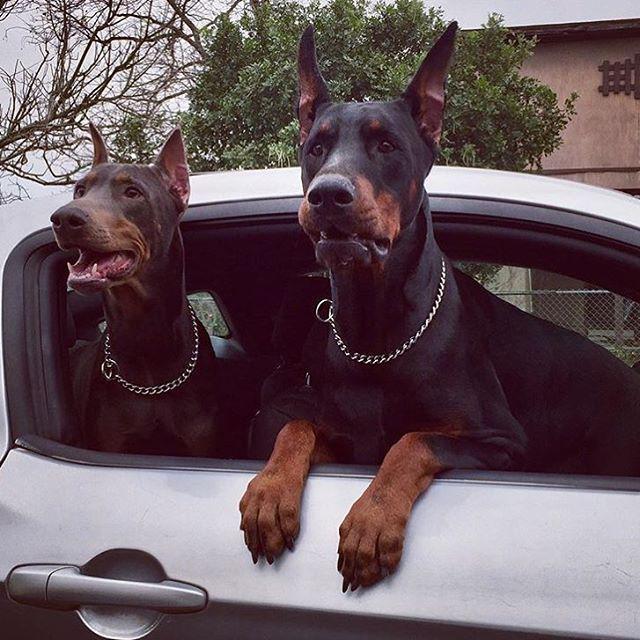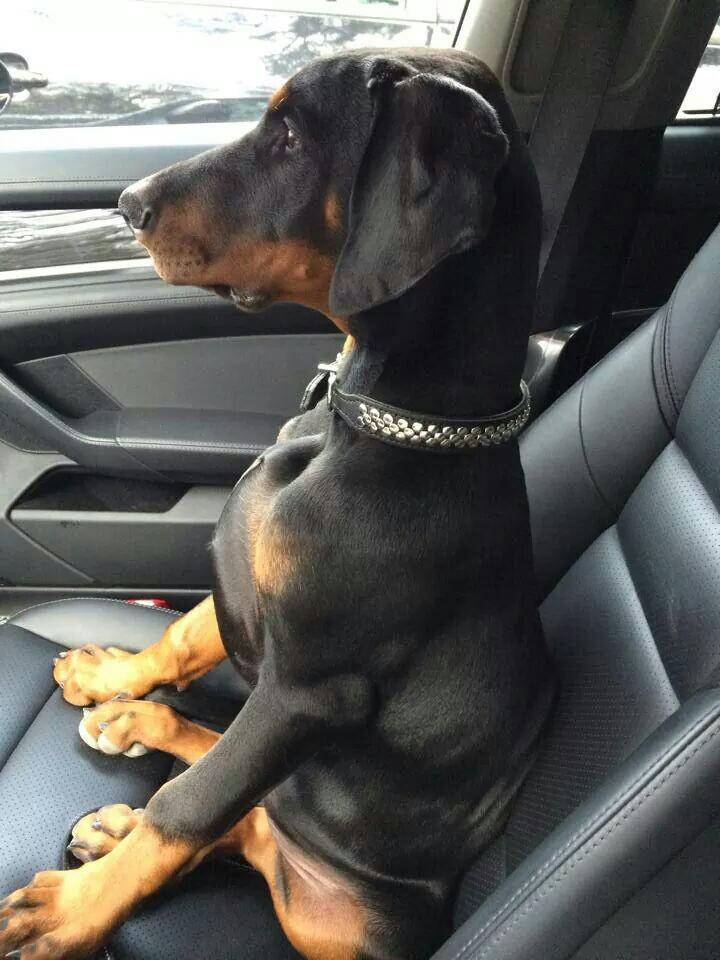The first image is the image on the left, the second image is the image on the right. Assess this claim about the two images: "There are 3 dogs in cars.". Correct or not? Answer yes or no. Yes. The first image is the image on the left, the second image is the image on the right. Assess this claim about the two images: "There are exactly three dogs in total.". Correct or not? Answer yes or no. Yes. 